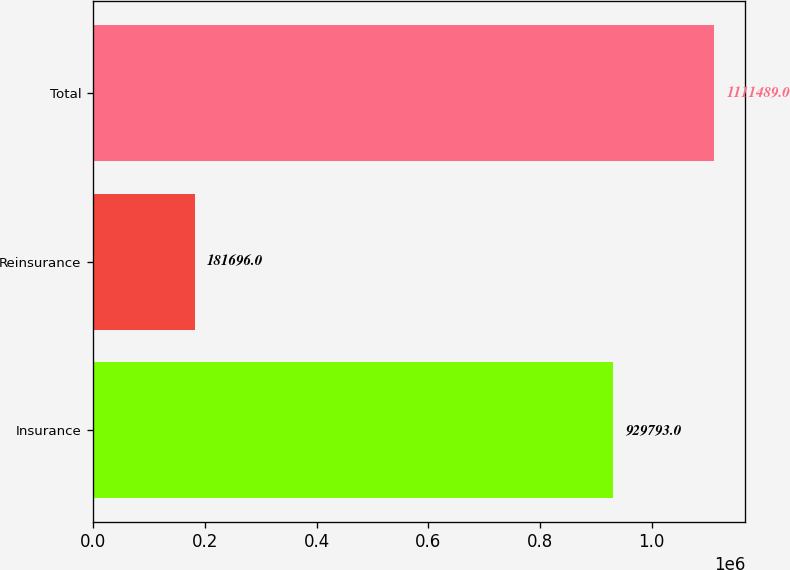<chart> <loc_0><loc_0><loc_500><loc_500><bar_chart><fcel>Insurance<fcel>Reinsurance<fcel>Total<nl><fcel>929793<fcel>181696<fcel>1.11149e+06<nl></chart> 